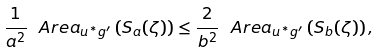Convert formula to latex. <formula><loc_0><loc_0><loc_500><loc_500>\frac { 1 } { a ^ { 2 } } \ A r e a _ { u ^ { * } g ^ { \prime } } \left ( S _ { a } ( \zeta ) \right ) \leq \frac { 2 } { b ^ { 2 } } \ A r e a _ { u ^ { * } g ^ { \prime } } \left ( S _ { b } ( \zeta ) \right ) ,</formula> 